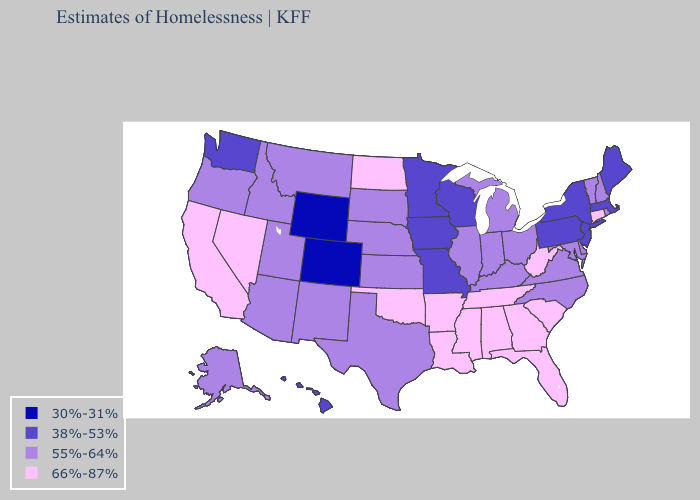Name the states that have a value in the range 55%-64%?
Write a very short answer. Alaska, Arizona, Delaware, Idaho, Illinois, Indiana, Kansas, Kentucky, Maryland, Michigan, Montana, Nebraska, New Hampshire, New Mexico, North Carolina, Ohio, Oregon, Rhode Island, South Dakota, Texas, Utah, Vermont, Virginia. What is the highest value in states that border Tennessee?
Be succinct. 66%-87%. Does Michigan have the same value as Arizona?
Concise answer only. Yes. What is the value of Maine?
Be succinct. 38%-53%. Name the states that have a value in the range 66%-87%?
Give a very brief answer. Alabama, Arkansas, California, Connecticut, Florida, Georgia, Louisiana, Mississippi, Nevada, North Dakota, Oklahoma, South Carolina, Tennessee, West Virginia. What is the value of Kentucky?
Short answer required. 55%-64%. Does North Dakota have the highest value in the MidWest?
Answer briefly. Yes. Name the states that have a value in the range 38%-53%?
Write a very short answer. Hawaii, Iowa, Maine, Massachusetts, Minnesota, Missouri, New Jersey, New York, Pennsylvania, Washington, Wisconsin. What is the highest value in states that border Mississippi?
Write a very short answer. 66%-87%. What is the value of Utah?
Be succinct. 55%-64%. Name the states that have a value in the range 30%-31%?
Quick response, please. Colorado, Wyoming. Name the states that have a value in the range 38%-53%?
Give a very brief answer. Hawaii, Iowa, Maine, Massachusetts, Minnesota, Missouri, New Jersey, New York, Pennsylvania, Washington, Wisconsin. What is the value of Alaska?
Keep it brief. 55%-64%. Name the states that have a value in the range 66%-87%?
Write a very short answer. Alabama, Arkansas, California, Connecticut, Florida, Georgia, Louisiana, Mississippi, Nevada, North Dakota, Oklahoma, South Carolina, Tennessee, West Virginia. What is the lowest value in the Northeast?
Keep it brief. 38%-53%. 